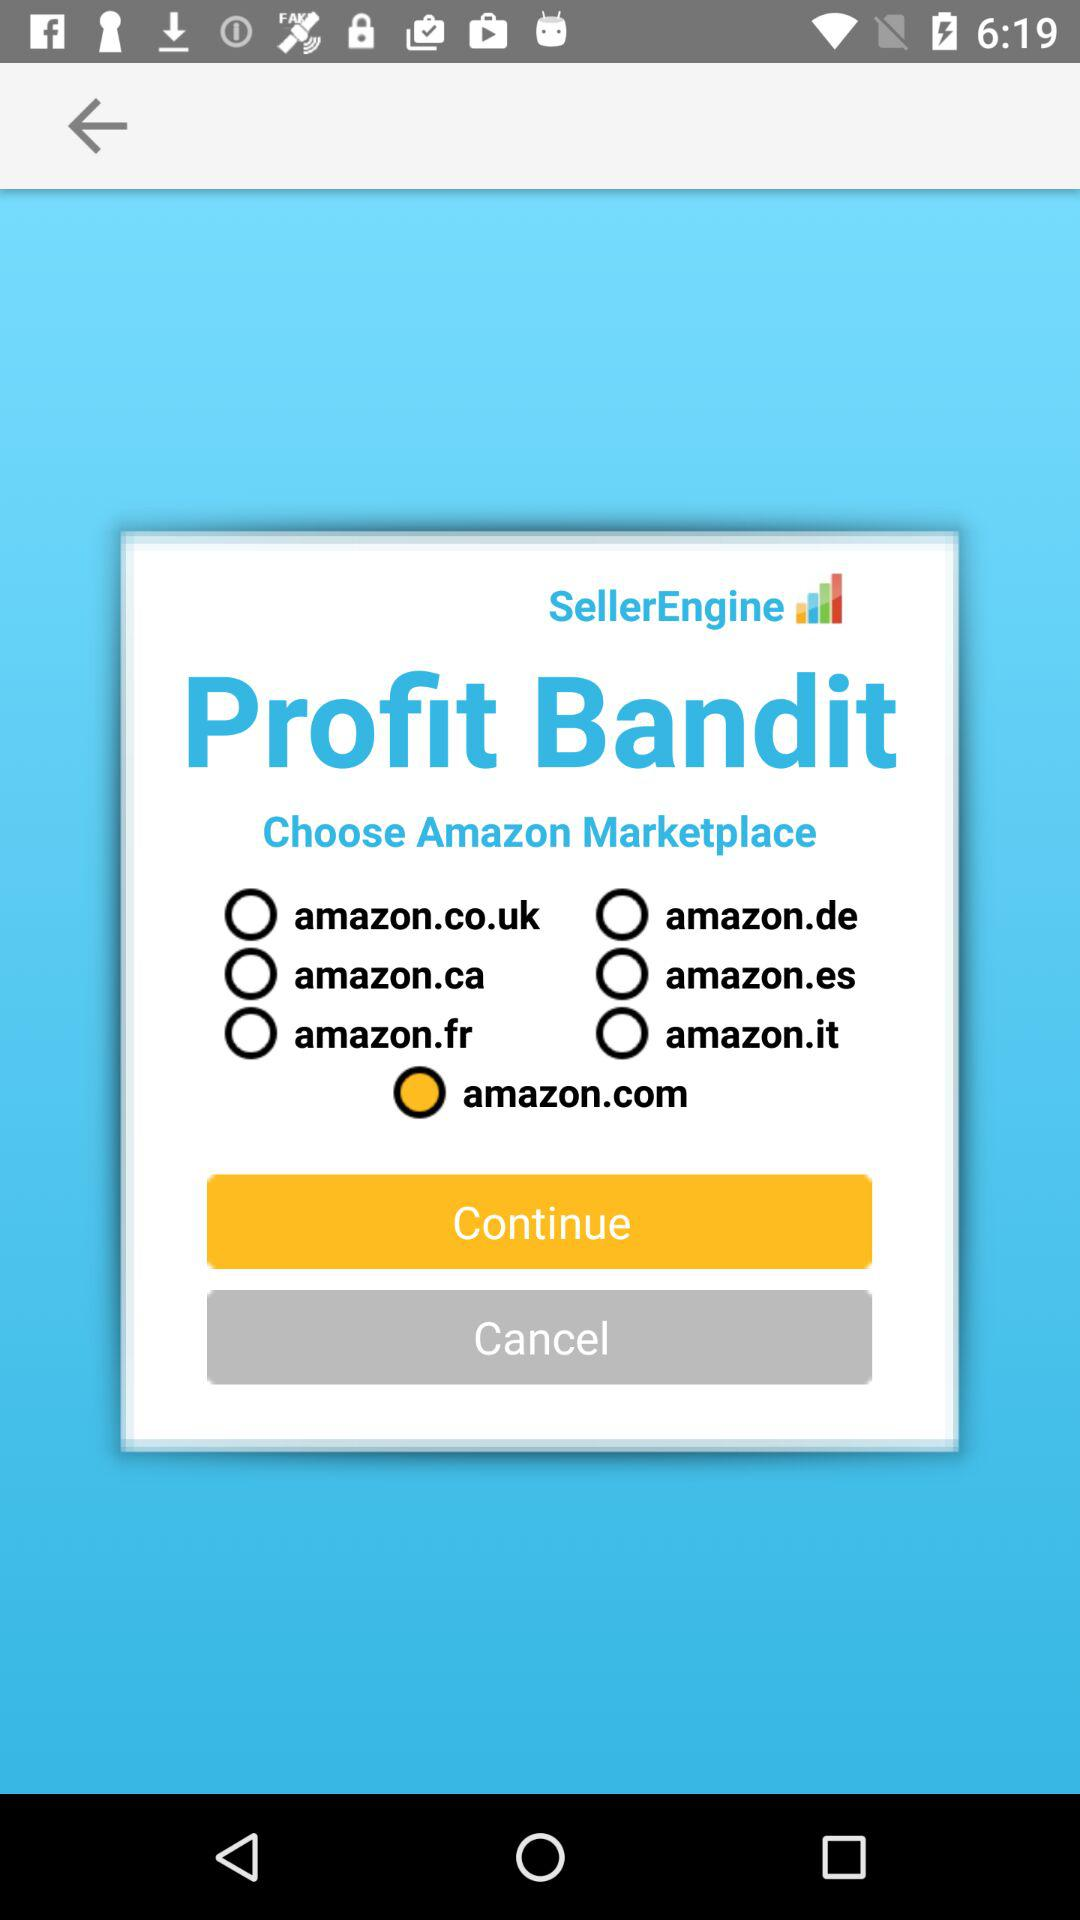How many Amazon marketplaces are available to choose from?
Answer the question using a single word or phrase. 7 